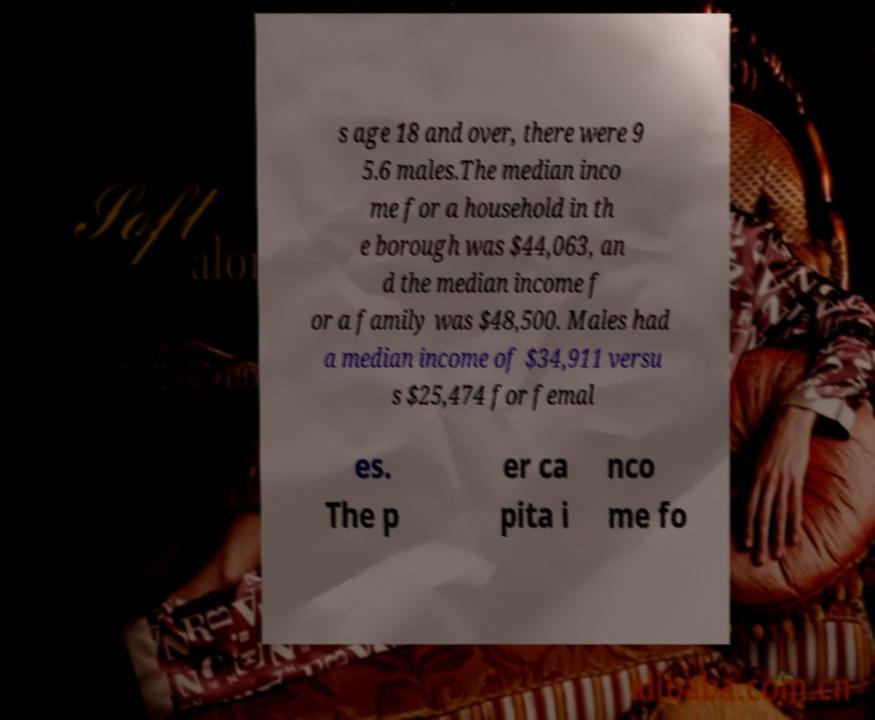I need the written content from this picture converted into text. Can you do that? s age 18 and over, there were 9 5.6 males.The median inco me for a household in th e borough was $44,063, an d the median income f or a family was $48,500. Males had a median income of $34,911 versu s $25,474 for femal es. The p er ca pita i nco me fo 